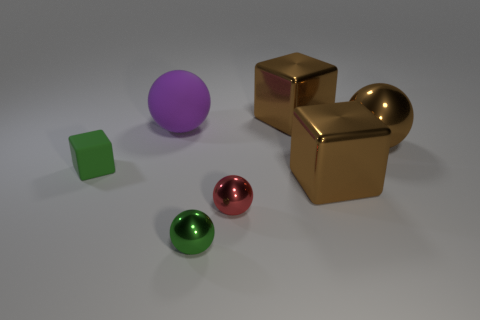Add 1 large blue balls. How many objects exist? 8 Subtract all blocks. How many objects are left? 4 Add 7 red metal things. How many red metal things are left? 8 Add 6 tiny shiny spheres. How many tiny shiny spheres exist? 8 Subtract 0 brown cylinders. How many objects are left? 7 Subtract all big brown metallic blocks. Subtract all big brown metallic things. How many objects are left? 2 